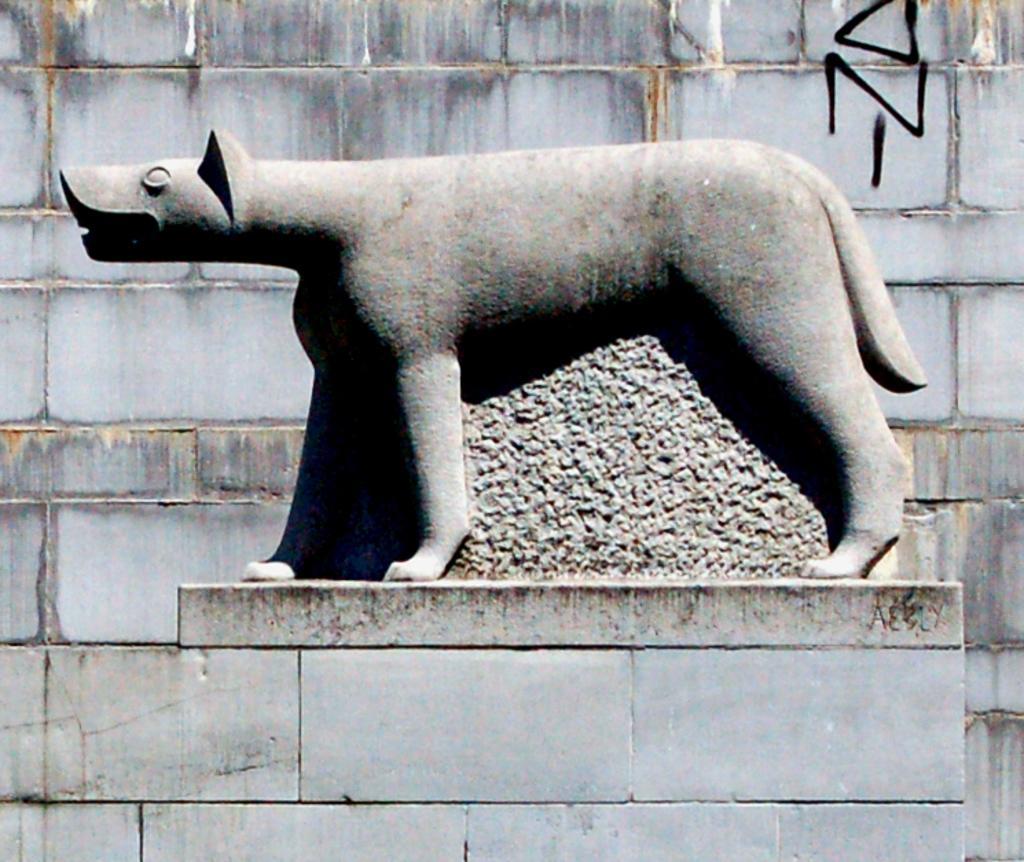What is the main subject in the image? There is a statue in the image. Where is the statue located? The statue is on a pillar. What can be seen in the background of the image? There is a wall in the background of the image. What type of bun is the statue holding in the image? There is no bun present in the image; the statue is not holding anything. Are the statue's brothers also visible in the image? There is no mention of brothers or any other figures in the image, only the statue on a pillar and a wall in the background. 